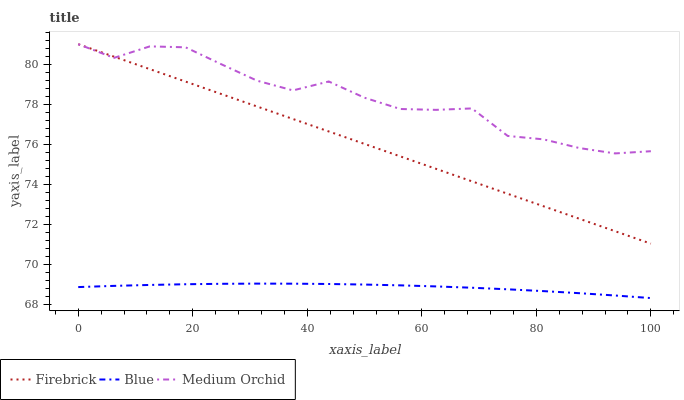Does Blue have the minimum area under the curve?
Answer yes or no. Yes. Does Medium Orchid have the maximum area under the curve?
Answer yes or no. Yes. Does Firebrick have the minimum area under the curve?
Answer yes or no. No. Does Firebrick have the maximum area under the curve?
Answer yes or no. No. Is Firebrick the smoothest?
Answer yes or no. Yes. Is Medium Orchid the roughest?
Answer yes or no. Yes. Is Medium Orchid the smoothest?
Answer yes or no. No. Is Firebrick the roughest?
Answer yes or no. No. Does Blue have the lowest value?
Answer yes or no. Yes. Does Firebrick have the lowest value?
Answer yes or no. No. Does Medium Orchid have the highest value?
Answer yes or no. Yes. Is Blue less than Firebrick?
Answer yes or no. Yes. Is Firebrick greater than Blue?
Answer yes or no. Yes. Does Medium Orchid intersect Firebrick?
Answer yes or no. Yes. Is Medium Orchid less than Firebrick?
Answer yes or no. No. Is Medium Orchid greater than Firebrick?
Answer yes or no. No. Does Blue intersect Firebrick?
Answer yes or no. No. 